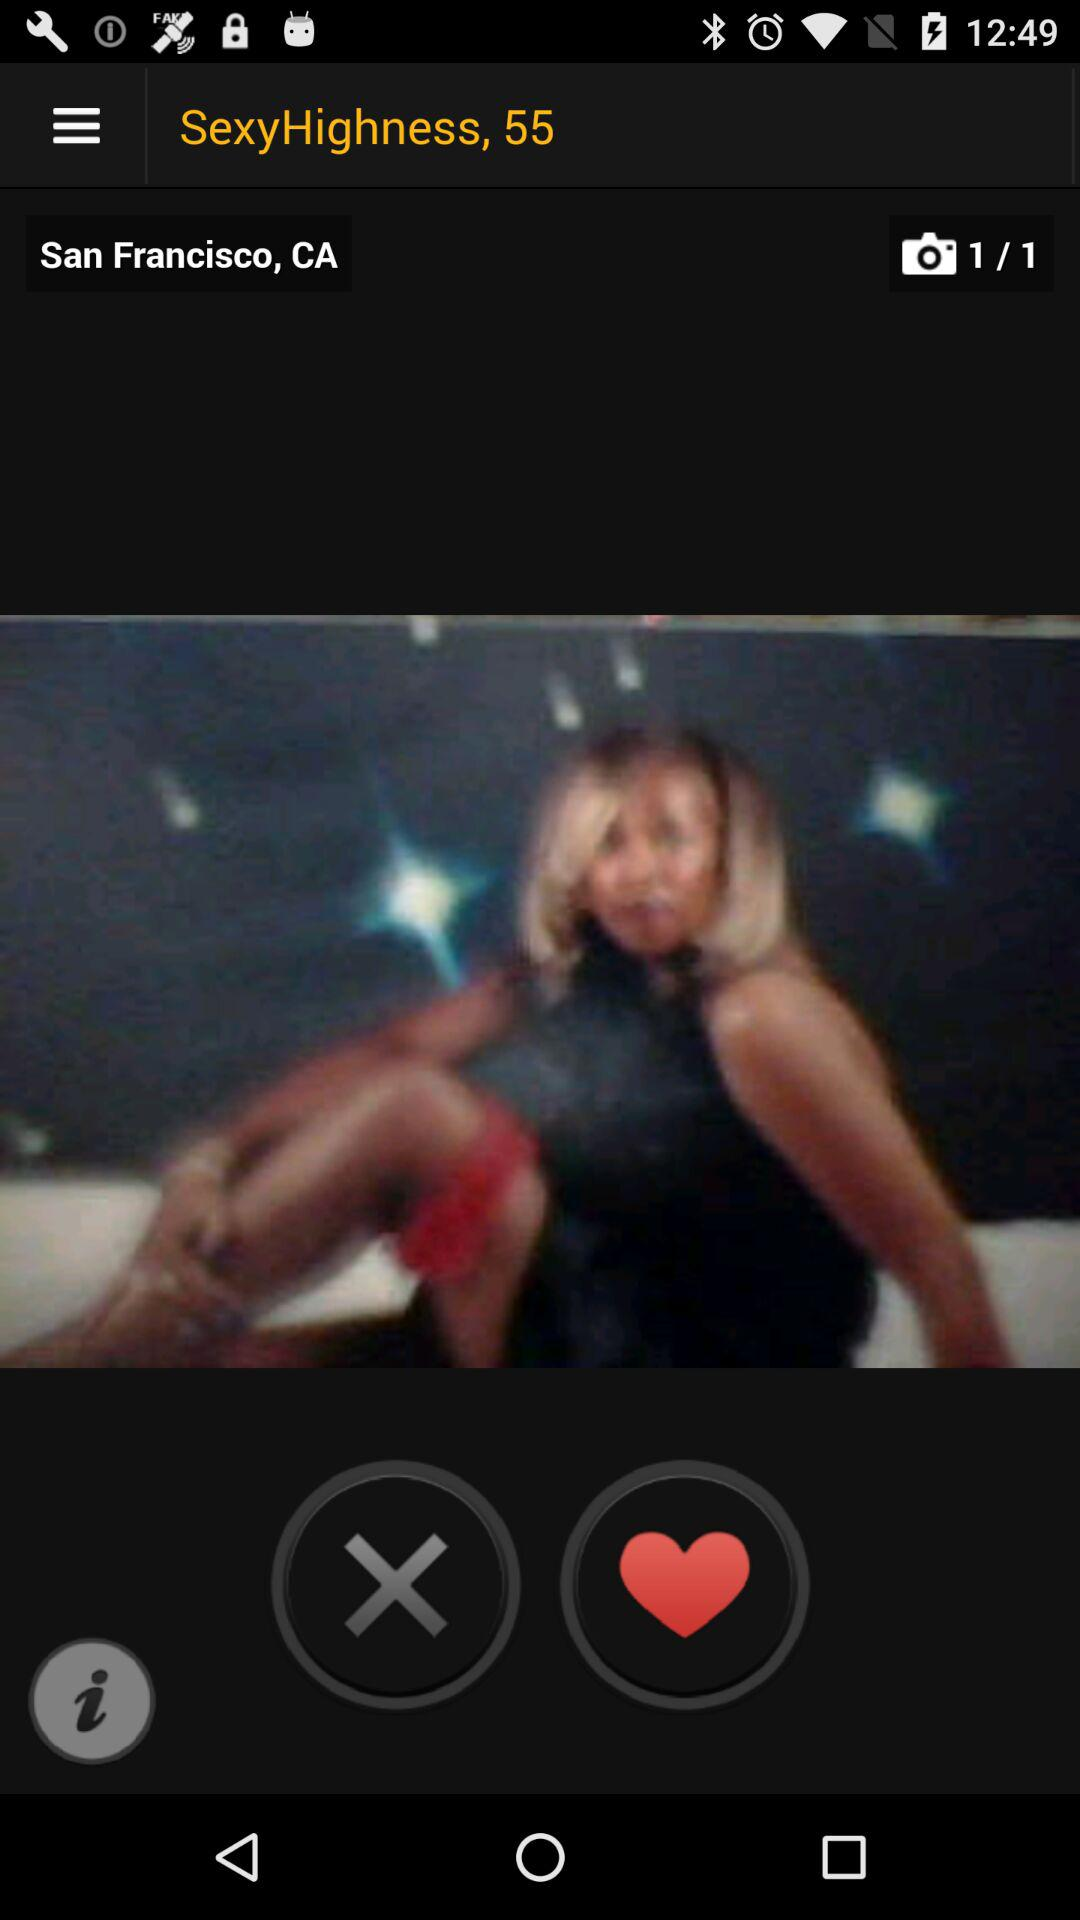How old is "SexyHighness"?
When the provided information is insufficient, respond with <no answer>. <no answer> 